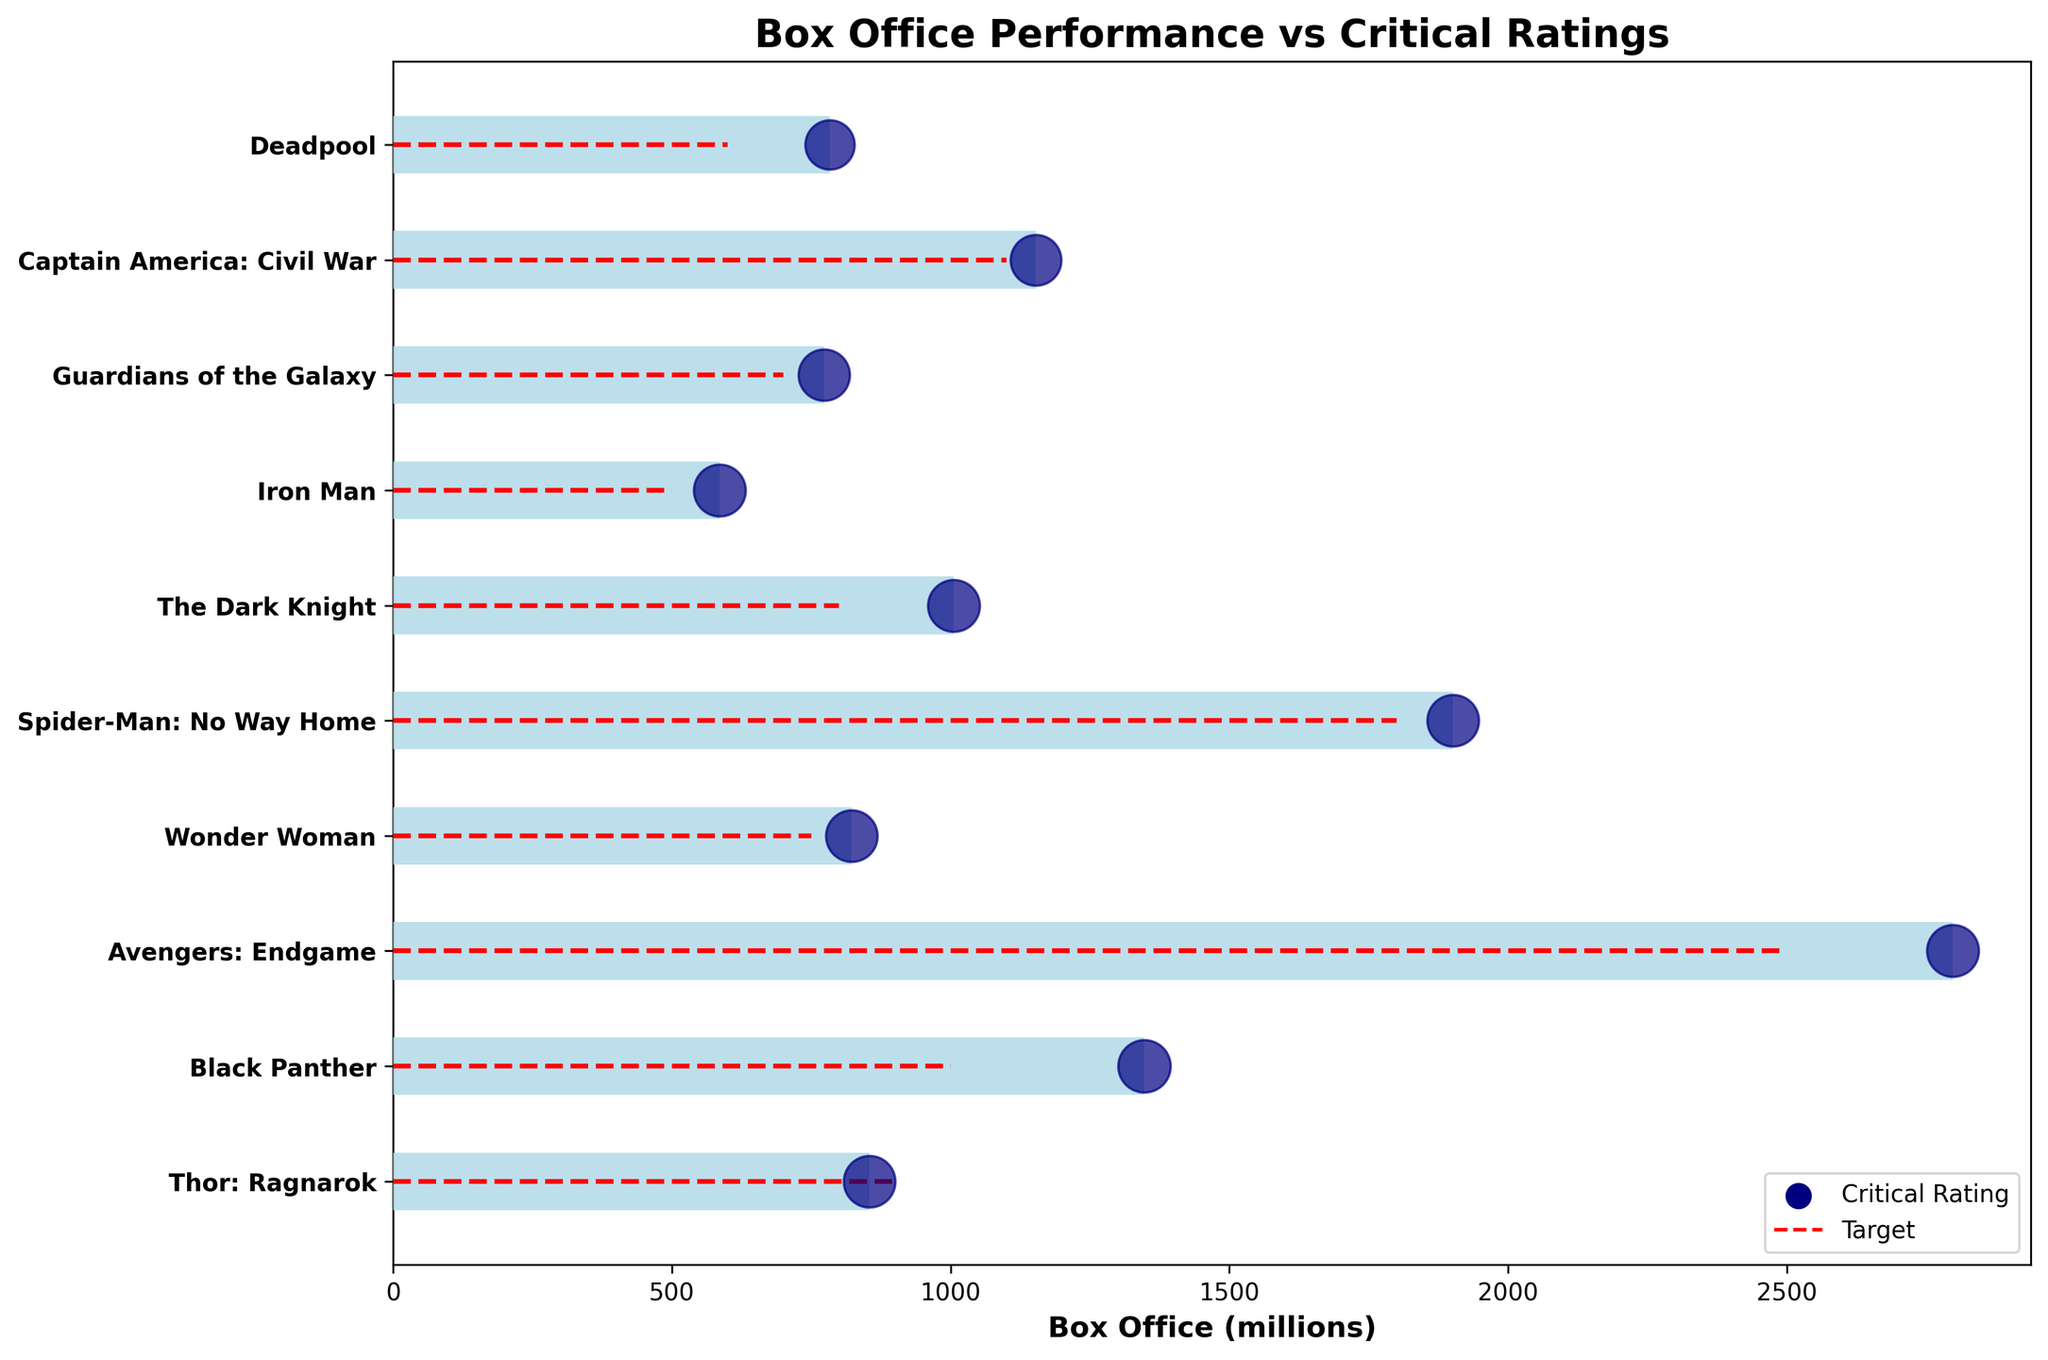How many movies have a box office performance above their target? By comparing the end of the light blue bars (box office performance) with the red dashed lines (the targets), we count the movies where the box office performance exceeds the target. These movies are "Black Panther", "Avengers: Endgame", "Deadpool", and "Spider-Man: No Way Home".
Answer: 4 What is the title of the movie with the highest box office revenue? Look at the end of the largest light blue bar for the box office performance. The movie with the highest box office performance is "Avengers: Endgame" with 2798 million.
Answer: Avengers: Endgame Which movie has the lowest critical rating, and what is that rating? Check the smallest navy blue dot. The lowest critical rating, indicated by the smallest dot, belongs to "Deadpool" with a rating of 85.
Answer: Deadpool, 85 What is the average box office revenue of "Thor: Ragnarok" and "Wonder Woman"? Add the box office revenues for both movies: 854 million (Thor: Ragnarok) + 822 million (Wonder Woman). Then, divide this sum by 2 to find the average. 854 + 822 = 1676; 1676 / 2 = 838.
Answer: 838 million Identify two movies with the same average critical rating of 94. Find the movies that have the same size of navy blue dots, representing a critical rating of 94. These movies are "Avengers: Endgame", "The Dark Knight", and "Iron Man".
Answer: Avengers: Endgame and The Dark Knight or Iron Man Which movie has a box office performance closest to its target? Calculate the absolute difference between the box office revenues and targets for each movie, then find the smallest difference. The smallest difference is between "Wonder Woman" (822) and its target (750), which is 72 million.
Answer: Wonder Woman How many movies have a critical rating below 90? Count the number of movies with navy blue dots that are sized to represent a rating below 90. The movies are "Deadpool" (85) and "Captain America: Civil War" (90).
Answer: 1 (Deadpool, if only considering strictly below 90) Which two movies combined have a lower box office revenue than "Spider-Man: No Way Home"? Add the box office revenues of different pairs of movies and compare them to "Spider-Man: No Way Home" (1901 million). "Thor: Ragnarok" (854) and "Wonder Woman" (822) together make 1676 million, which is less than 1901 million.
Answer: Thor: Ragnarok and Wonder Woman What is the range of box office performances among the movies listed? Find the highest and lowest box office performances and subtract the lowest from the highest. The highest is "Avengers: Endgame" (2798 million) and the lowest is "Iron Man" (585 million). 2798 - 585 = 2213.
Answer: 2213 million 